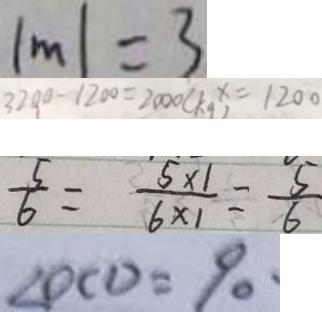Convert formula to latex. <formula><loc_0><loc_0><loc_500><loc_500>\vert m \vert = 3 
 3 2 0 0 - 1 2 0 0 = 2 0 0 0 ( k g ) x = 1 2 0 0 
 \frac { 5 } { 6 } = \frac { 5 \times 1 } { 6 \times 1 } = \frac { 5 } { 6 } 
 \angle D C D = 9 0 ^ { \circ }</formula> 